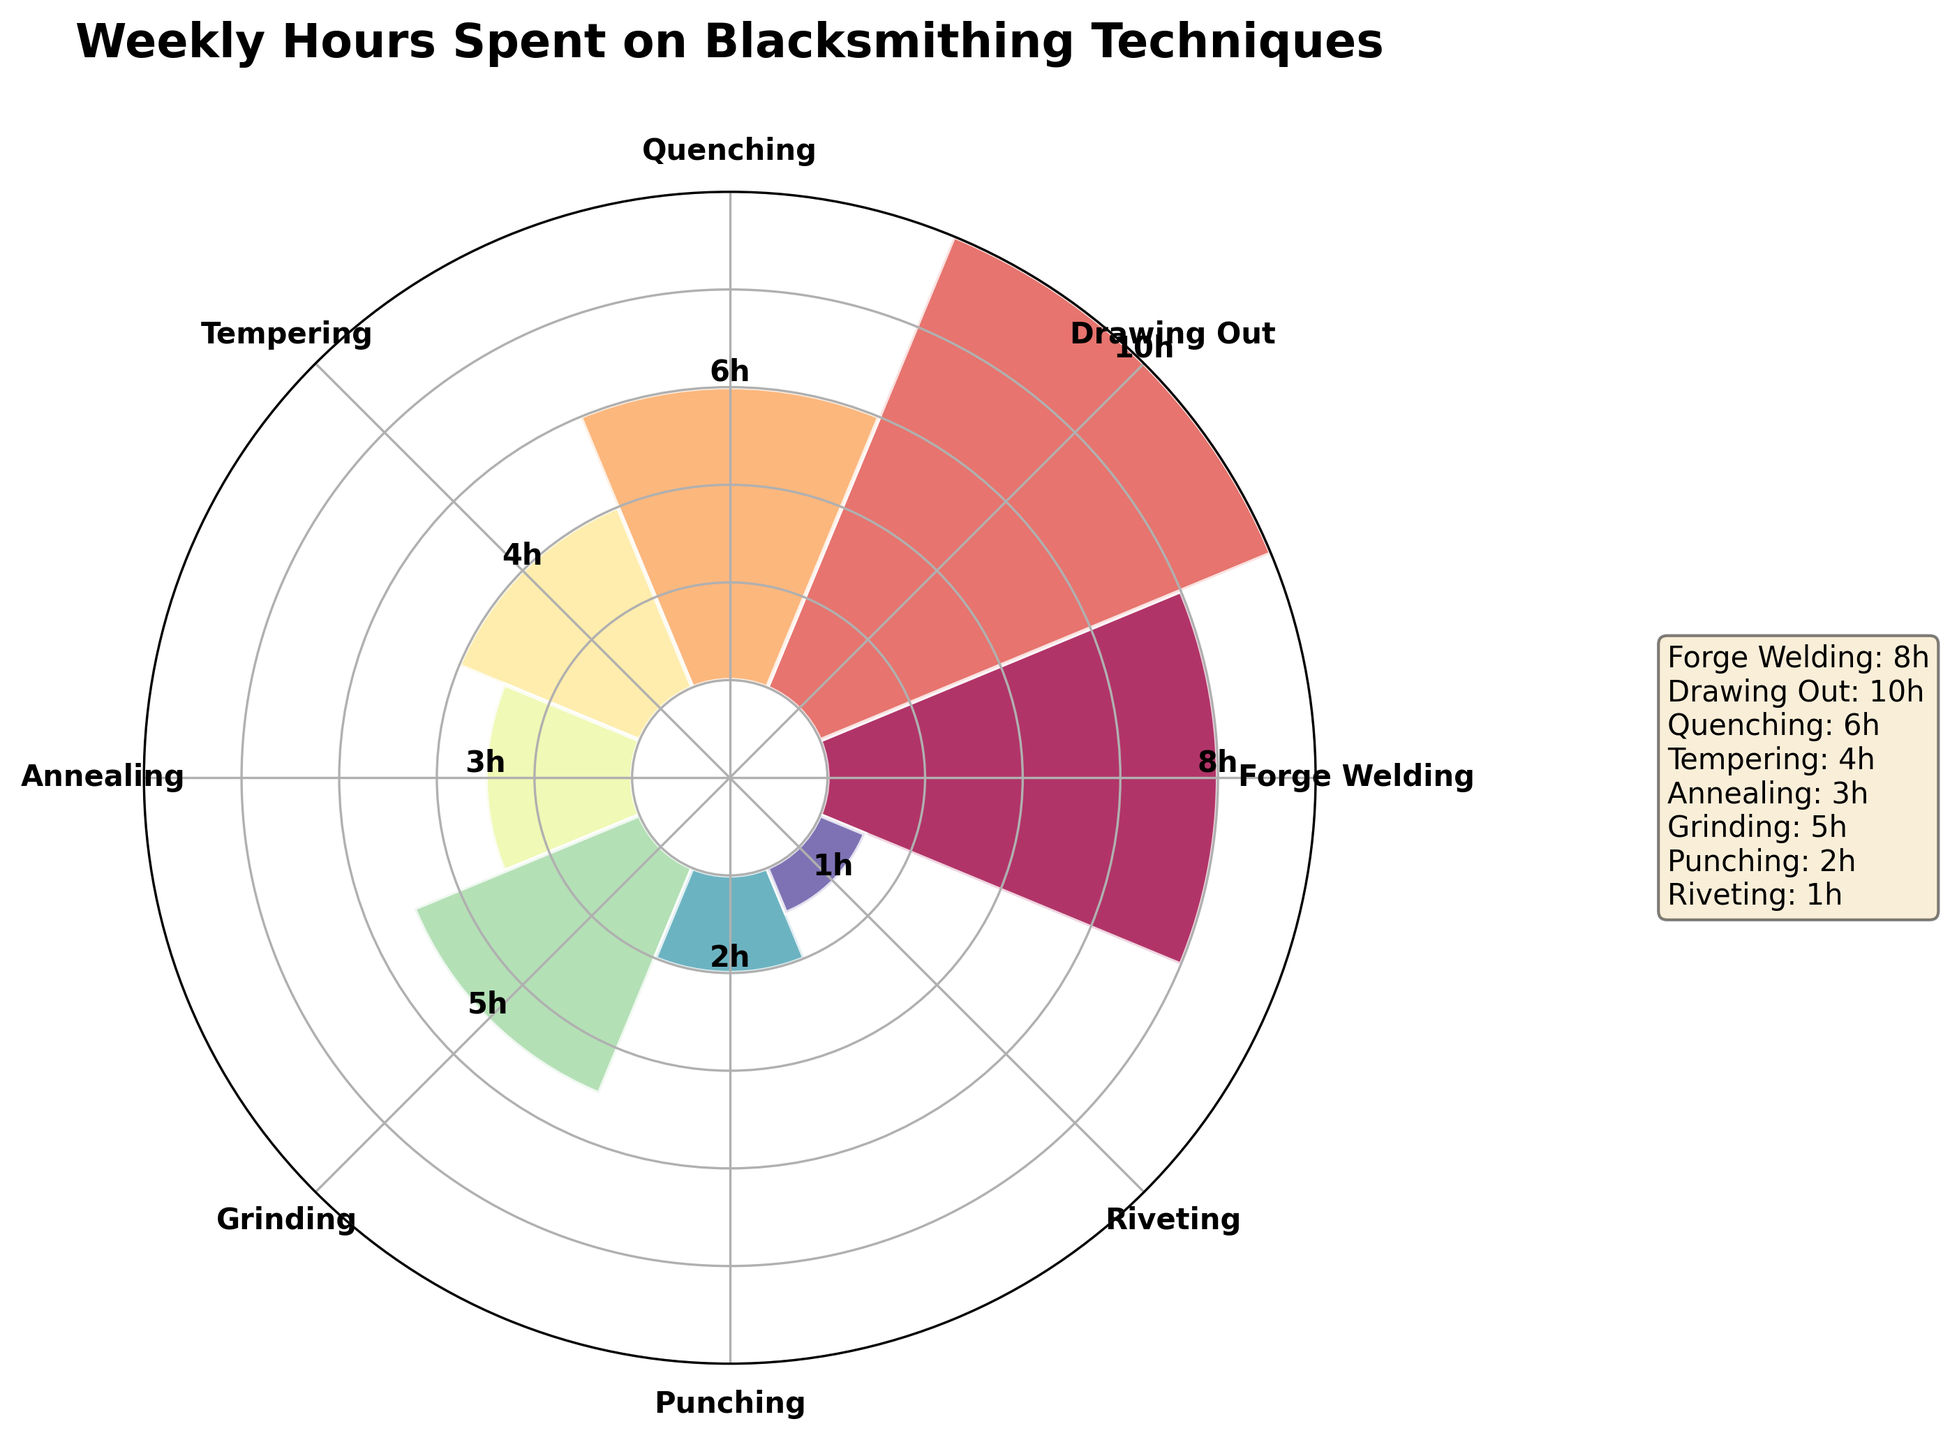Which technique has the highest number of hours spent? The bar representing "Drawing Out" extends the highest on the rose chart with a label showing 10 hours.
Answer: Drawing Out What is the total time spent on Quenching, Tempering, and Annealing combined? According to the chart, Quenching takes 6 hours, Tempering 4 hours, and Annealing 3 hours. Summing these values gives 6 + 4 + 3 = 13 hours.
Answer: 13 hours Which technique has the least amount of time spent? The smallest bar on the chart corresponds to "Riveting," labeled as 1 hour.
Answer: Riveting How many techniques have more than 5 hours of work per week? From the chart, the techniques with more than 5 hours are Forge Welding (8 hours), Drawing Out (10 hours), and Quenching (6 hours). That totals to 3 techniques.
Answer: 3 What is the average number of hours spent on Grinding and Punching? Grinding takes 5 hours and Punching takes 2 hours. The average is calculated as (5 + 2) / 2 = 7 / 2 = 3.5 hours.
Answer: 3.5 hours Which technique graphically appears at the 90-degree position on the chart? The technique labeled at the theta angle corresponding to 90 degrees (π/2 radians) is "Drawing Out."
Answer: Drawing Out By what percentage does the time spent on Tempering exceed that of Punching? Time spent on Tempering is 4 hours, while for Punching, it is 2 hours. The percentage increase is calculated as ((4 - 2) / 2) * 100 = 100%.
Answer: 100% How much more time is spent on Forge Welding compared to Annealing? The chart shows 8 hours for Forge Welding and 3 hours for Annealing. The difference is 8 - 3 = 5 hours.
Answer: 5 hours 